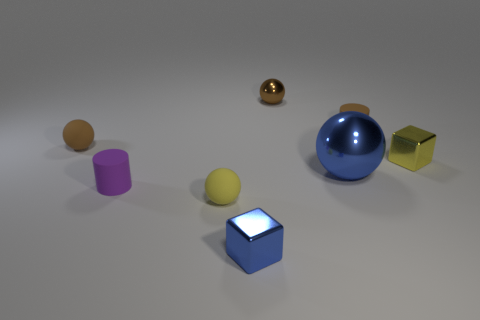There is a small yellow object that is on the left side of the brown cylinder; is its shape the same as the tiny purple thing?
Offer a very short reply. No. There is a tiny cube on the left side of the small yellow metallic object; what is it made of?
Offer a very short reply. Metal. What is the shape of the small object that is to the right of the small shiny sphere and on the left side of the yellow cube?
Keep it short and to the point. Cylinder. What material is the yellow block?
Your response must be concise. Metal. What number of spheres are either big brown shiny objects or blue metal things?
Offer a very short reply. 1. Does the yellow ball have the same material as the purple object?
Offer a very short reply. Yes. There is a brown metal thing that is the same shape as the yellow matte object; what is its size?
Keep it short and to the point. Small. There is a object that is to the right of the brown metallic thing and behind the small brown rubber ball; what is its material?
Keep it short and to the point. Rubber. Is the number of small brown metal things left of the brown metal object the same as the number of big yellow matte spheres?
Keep it short and to the point. Yes. How many objects are either tiny metal objects on the right side of the small brown rubber ball or big balls?
Keep it short and to the point. 4. 